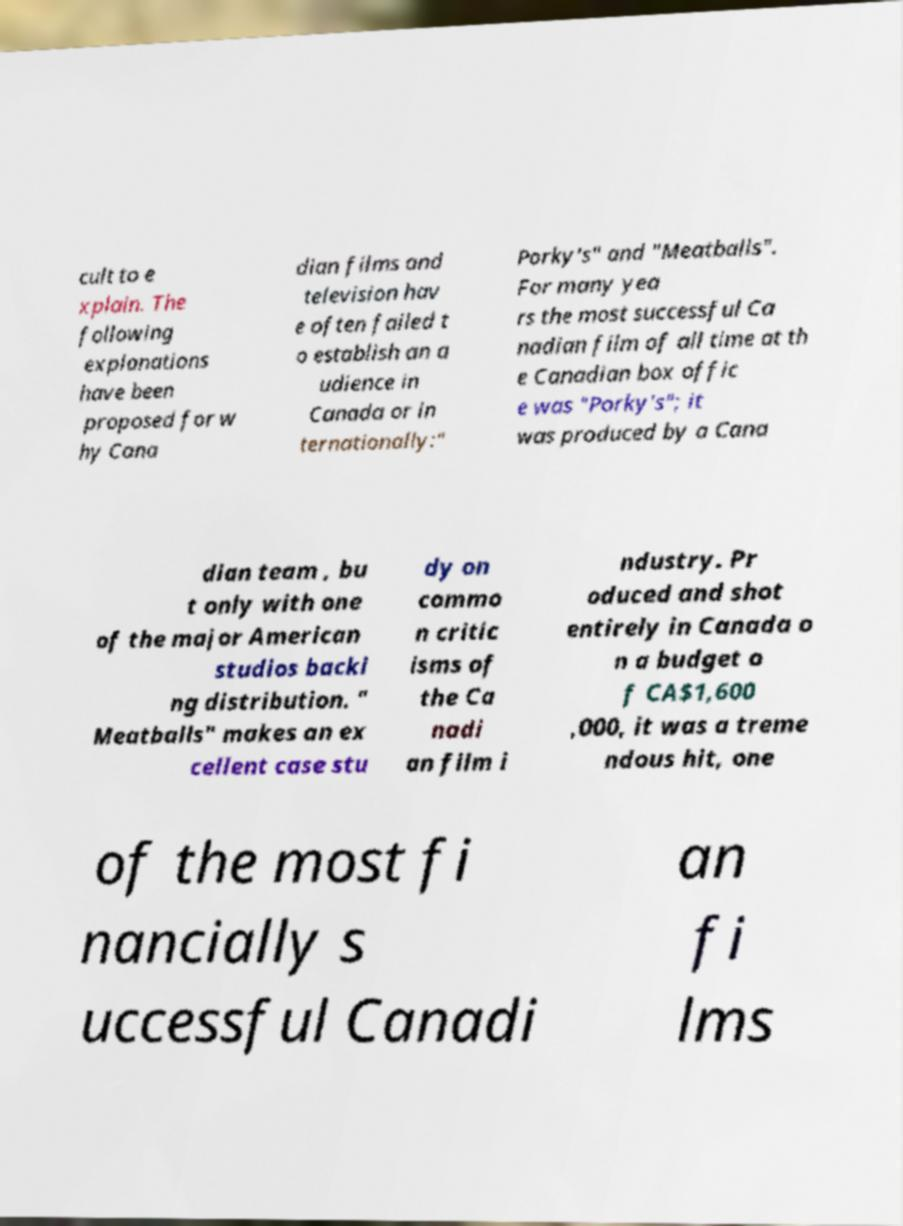What messages or text are displayed in this image? I need them in a readable, typed format. cult to e xplain. The following explanations have been proposed for w hy Cana dian films and television hav e often failed t o establish an a udience in Canada or in ternationally:" Porky's" and "Meatballs". For many yea rs the most successful Ca nadian film of all time at th e Canadian box offic e was "Porky's"; it was produced by a Cana dian team , bu t only with one of the major American studios backi ng distribution. " Meatballs" makes an ex cellent case stu dy on commo n critic isms of the Ca nadi an film i ndustry. Pr oduced and shot entirely in Canada o n a budget o f CA$1,600 ,000, it was a treme ndous hit, one of the most fi nancially s uccessful Canadi an fi lms 